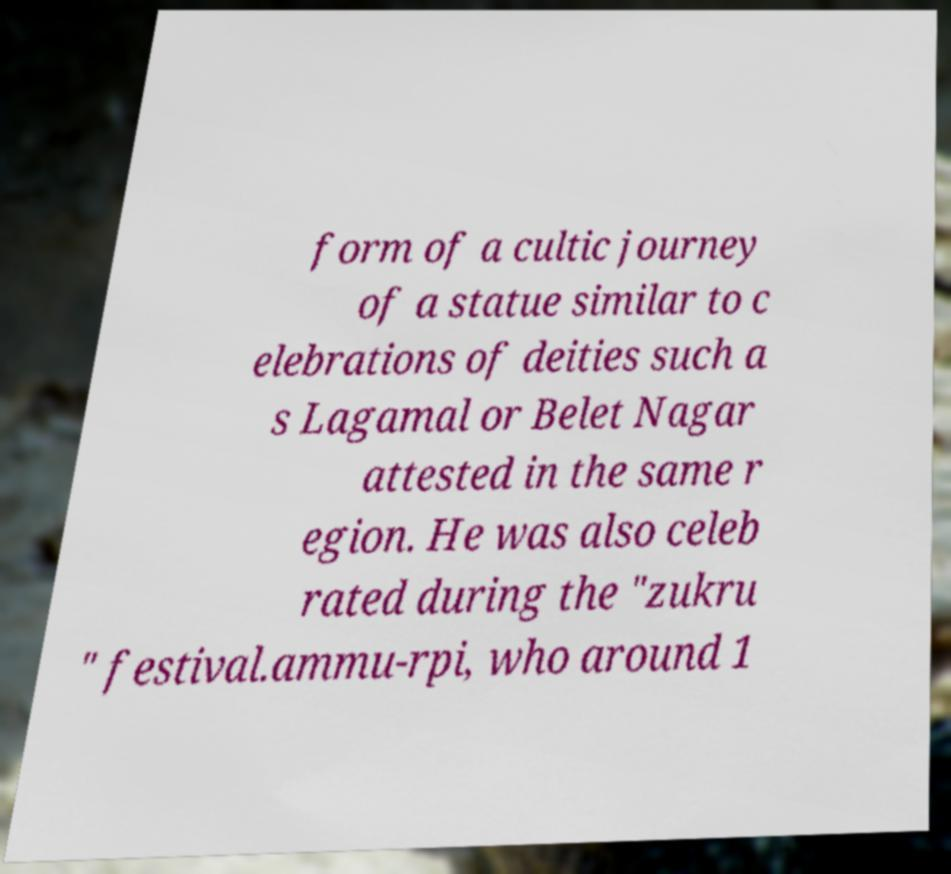For documentation purposes, I need the text within this image transcribed. Could you provide that? form of a cultic journey of a statue similar to c elebrations of deities such a s Lagamal or Belet Nagar attested in the same r egion. He was also celeb rated during the "zukru " festival.ammu-rpi, who around 1 